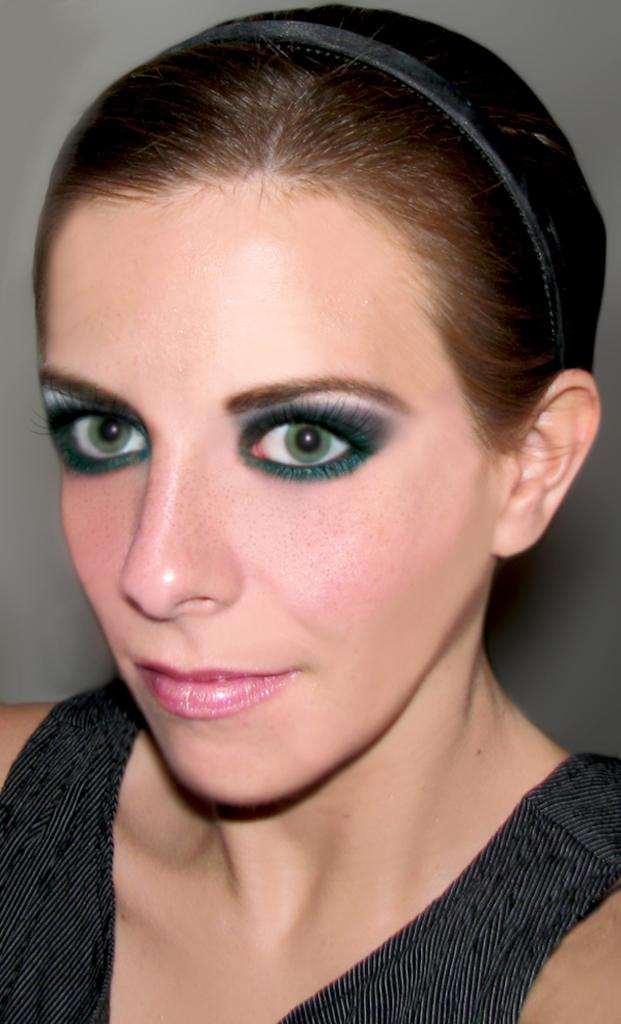Who is the main subject in the image? There is a woman in the image. Where is the woman located in the image? The woman is in the center of the image. What is the woman wearing in the image? The woman is wearing a black dress and a black hair band. What type of bells can be heard ringing in the image? There are no bells present in the image, and therefore no sound can be heard. 